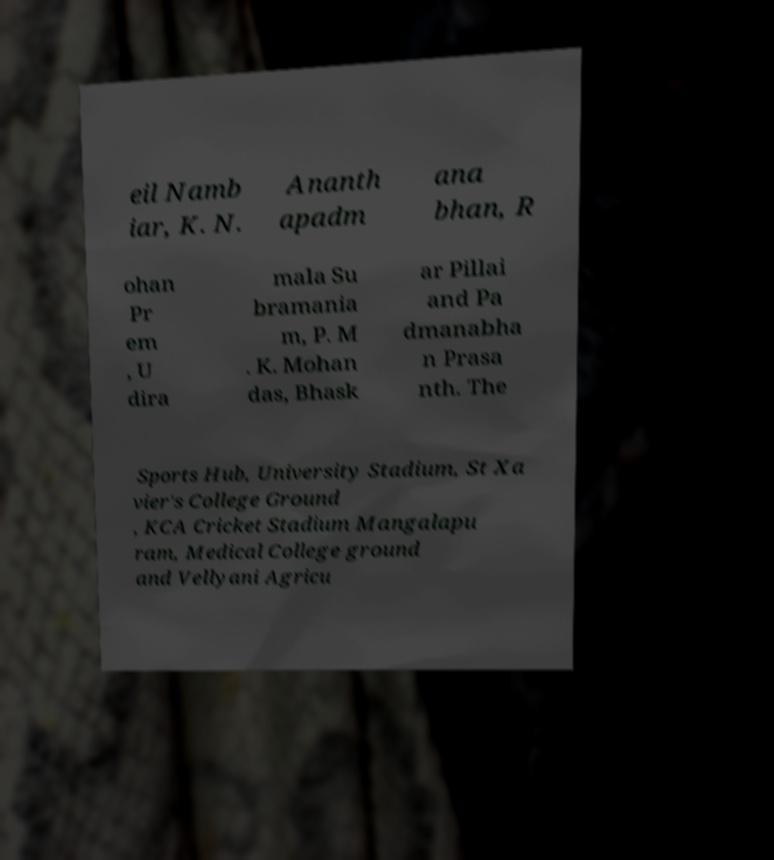Can you accurately transcribe the text from the provided image for me? eil Namb iar, K. N. Ananth apadm ana bhan, R ohan Pr em , U dira mala Su bramania m, P. M . K. Mohan das, Bhask ar Pillai and Pa dmanabha n Prasa nth. The Sports Hub, University Stadium, St Xa vier's College Ground , KCA Cricket Stadium Mangalapu ram, Medical College ground and Vellyani Agricu 